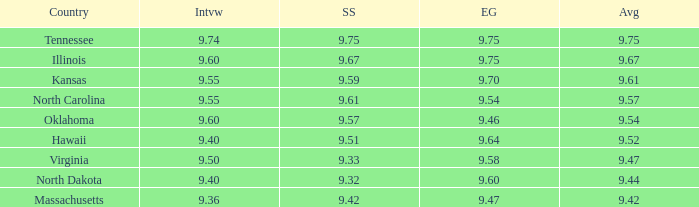What was the average for the country with the swimsuit score of 9.57? 9.54. 